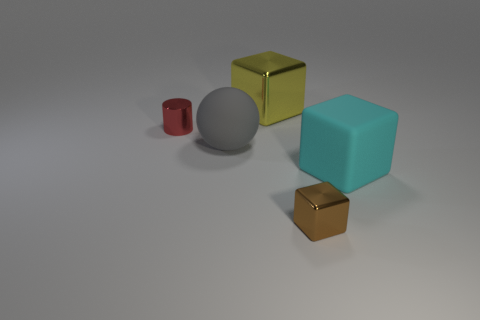The metal thing that is left of the shiny block that is left of the shiny object right of the large yellow shiny cube is what color?
Your response must be concise. Red. There is a cube that is behind the large gray ball; is its size the same as the block that is right of the small shiny block?
Provide a short and direct response. Yes. Is there a big yellow metal object in front of the small thing behind the big rubber thing behind the matte cube?
Give a very brief answer. No. There is a metal block behind the small object behind the small metallic object on the right side of the big yellow block; what size is it?
Keep it short and to the point. Large. Is the color of the big cube that is in front of the tiny red shiny object the same as the small metallic object that is to the right of the shiny cylinder?
Your answer should be compact. No. Is the material of the small thing to the right of the gray matte thing the same as the tiny thing behind the big gray rubber object?
Offer a terse response. Yes. Are there fewer tiny brown shiny blocks than large purple shiny cylinders?
Ensure brevity in your answer.  No. There is a tiny metal thing that is behind the tiny metal object in front of the red metal thing; what is its shape?
Give a very brief answer. Cylinder. The cyan rubber thing that is the same size as the matte sphere is what shape?
Keep it short and to the point. Cube. Are there any large green metallic objects of the same shape as the brown object?
Your answer should be compact. No. 